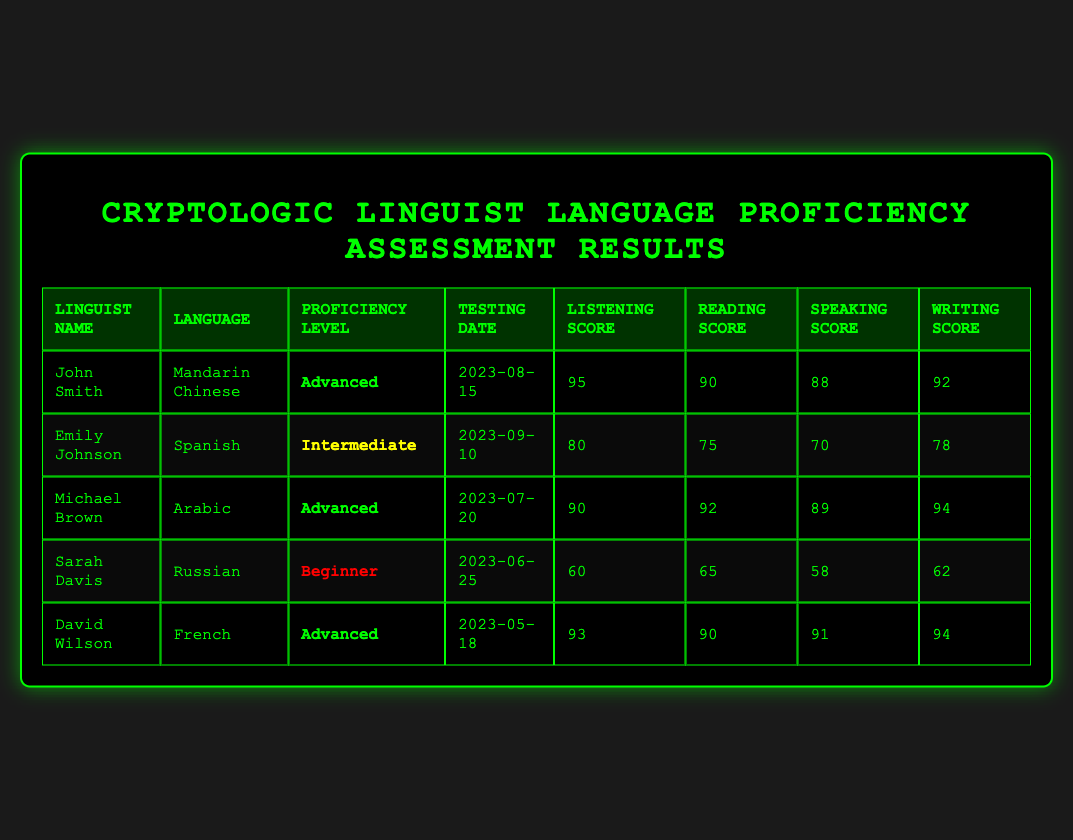What is the highest Listening Score recorded in the table? The highest Listening Score can be found by comparing all the values in the Listening Score column. The scores are 95, 80, 90, 60, and 93. The highest of these is 95, recorded by John Smith for Mandarin Chinese.
Answer: 95 Which linguist has an Intermediate proficiency level? The table has a column for Proficiency Level. Looking through this column, the only individual marked as Intermediate is Emily Johnson who speaks Spanish.
Answer: Emily Johnson What is the average Writing Score of all the linguists? To find the average Writing Score, first, sum all the Writing Scores: 92 + 78 + 94 + 62 + 94 = 420. There are 5 linguists, so we divide by 5 to get the average: 420/5 = 84.
Answer: 84 Did any linguist achieve a perfect score in any section? Checking each score against 100 confirms that no scores reach 100. Therefore, no linguist achieved a perfect score in any section.
Answer: No What is the difference in Listening Scores between the highest and lowest scores? From the Listening Scores, the highest is 95 (John Smith) and the lowest is 60 (Sarah Davis). The difference is calculated as 95 - 60 = 35.
Answer: 35 Which language has the lowest Reading Score and what is that score? To identify the language with the lowest Reading Score, the scores are: 90, 75, 92, 65, and 90. The lowest score is 65, which is associated with the language Russian spoken by Sarah Davis.
Answer: Russian, 65 Are there more Advanced proficiency linguists than Beginner proficiency linguists? By analyzing the Proficiency Level column, there are 3 Advanced proficiency linguists (John Smith, Michael Brown, David Wilson) and 1 Beginner proficiency linguist (Sarah Davis). Therefore, the answer is yes.
Answer: Yes Which linguist tested last according to the Testing Date? The Testing Date column shows dates: 2023-08-15, 2023-09-10, 2023-07-20, 2023-06-25, and 2023-05-18. The latest date is 2023-09-10, which corresponds to Emily Johnson.
Answer: Emily Johnson 